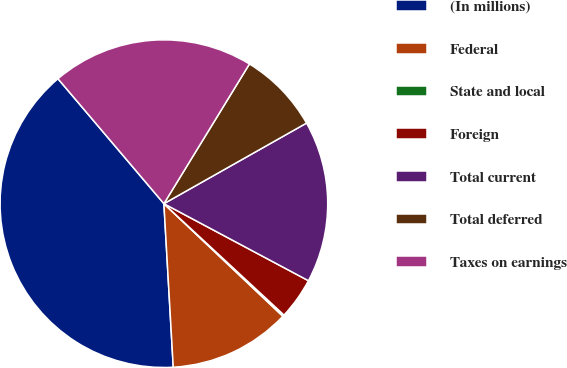Convert chart. <chart><loc_0><loc_0><loc_500><loc_500><pie_chart><fcel>(In millions)<fcel>Federal<fcel>State and local<fcel>Foreign<fcel>Total current<fcel>Total deferred<fcel>Taxes on earnings<nl><fcel>39.72%<fcel>12.03%<fcel>0.16%<fcel>4.11%<fcel>15.98%<fcel>8.07%<fcel>19.94%<nl></chart> 